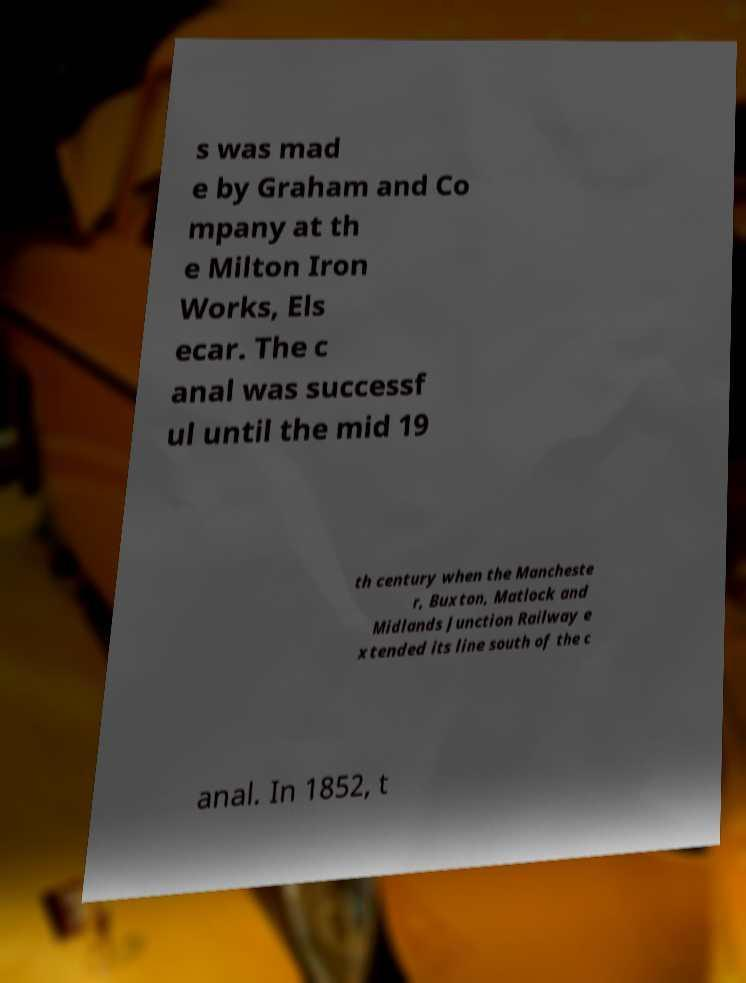Can you read and provide the text displayed in the image?This photo seems to have some interesting text. Can you extract and type it out for me? s was mad e by Graham and Co mpany at th e Milton Iron Works, Els ecar. The c anal was successf ul until the mid 19 th century when the Mancheste r, Buxton, Matlock and Midlands Junction Railway e xtended its line south of the c anal. In 1852, t 